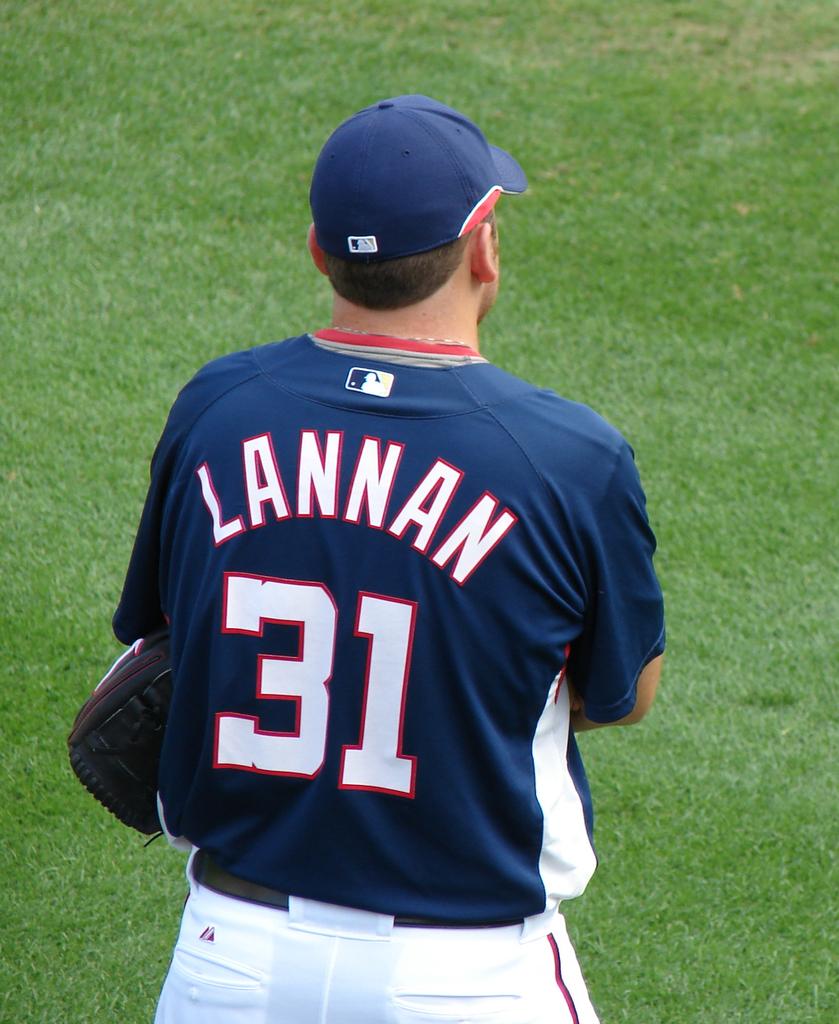What number jersey does lannan where?
Your response must be concise. 31. 